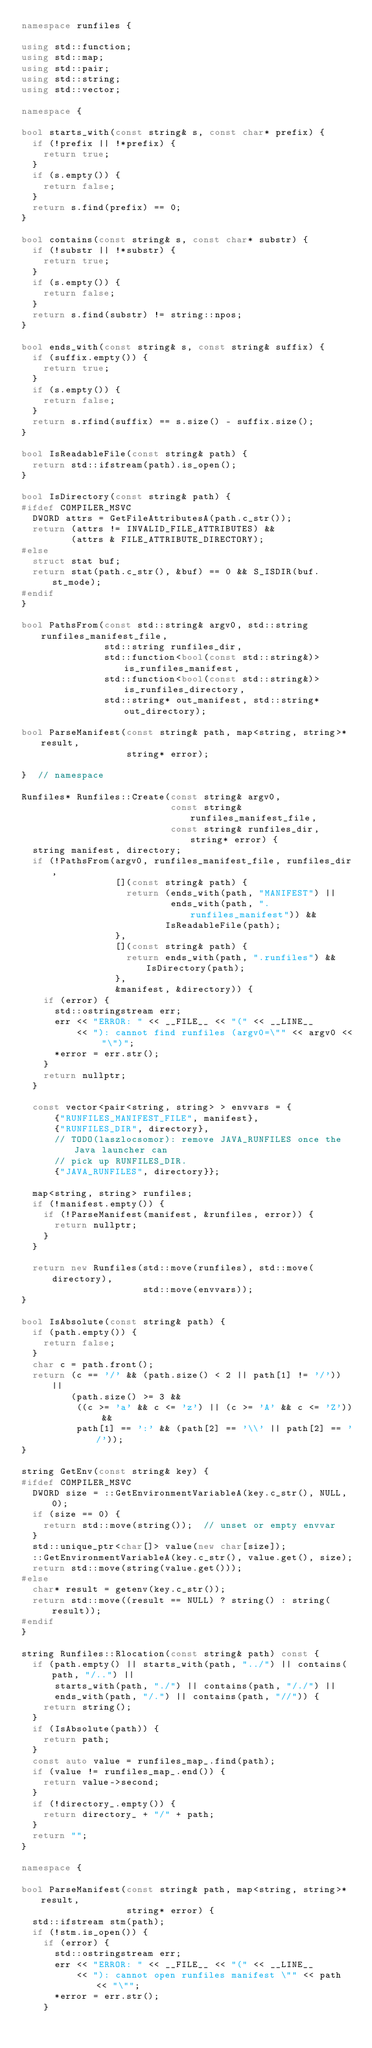Convert code to text. <code><loc_0><loc_0><loc_500><loc_500><_C++_>namespace runfiles {

using std::function;
using std::map;
using std::pair;
using std::string;
using std::vector;

namespace {

bool starts_with(const string& s, const char* prefix) {
  if (!prefix || !*prefix) {
    return true;
  }
  if (s.empty()) {
    return false;
  }
  return s.find(prefix) == 0;
}

bool contains(const string& s, const char* substr) {
  if (!substr || !*substr) {
    return true;
  }
  if (s.empty()) {
    return false;
  }
  return s.find(substr) != string::npos;
}

bool ends_with(const string& s, const string& suffix) {
  if (suffix.empty()) {
    return true;
  }
  if (s.empty()) {
    return false;
  }
  return s.rfind(suffix) == s.size() - suffix.size();
}

bool IsReadableFile(const string& path) {
  return std::ifstream(path).is_open();
}

bool IsDirectory(const string& path) {
#ifdef COMPILER_MSVC
  DWORD attrs = GetFileAttributesA(path.c_str());
  return (attrs != INVALID_FILE_ATTRIBUTES) &&
         (attrs & FILE_ATTRIBUTE_DIRECTORY);
#else
  struct stat buf;
  return stat(path.c_str(), &buf) == 0 && S_ISDIR(buf.st_mode);
#endif
}

bool PathsFrom(const std::string& argv0, std::string runfiles_manifest_file,
               std::string runfiles_dir,
               std::function<bool(const std::string&)> is_runfiles_manifest,
               std::function<bool(const std::string&)> is_runfiles_directory,
               std::string* out_manifest, std::string* out_directory);

bool ParseManifest(const string& path, map<string, string>* result,
                   string* error);

}  // namespace

Runfiles* Runfiles::Create(const string& argv0,
                           const string& runfiles_manifest_file,
                           const string& runfiles_dir, string* error) {
  string manifest, directory;
  if (!PathsFrom(argv0, runfiles_manifest_file, runfiles_dir,
                 [](const string& path) {
                   return (ends_with(path, "MANIFEST") ||
                           ends_with(path, ".runfiles_manifest")) &&
                          IsReadableFile(path);
                 },
                 [](const string& path) {
                   return ends_with(path, ".runfiles") && IsDirectory(path);
                 },
                 &manifest, &directory)) {
    if (error) {
      std::ostringstream err;
      err << "ERROR: " << __FILE__ << "(" << __LINE__
          << "): cannot find runfiles (argv0=\"" << argv0 << "\")";
      *error = err.str();
    }
    return nullptr;
  }

  const vector<pair<string, string> > envvars = {
      {"RUNFILES_MANIFEST_FILE", manifest},
      {"RUNFILES_DIR", directory},
      // TODO(laszlocsomor): remove JAVA_RUNFILES once the Java launcher can
      // pick up RUNFILES_DIR.
      {"JAVA_RUNFILES", directory}};

  map<string, string> runfiles;
  if (!manifest.empty()) {
    if (!ParseManifest(manifest, &runfiles, error)) {
      return nullptr;
    }
  }

  return new Runfiles(std::move(runfiles), std::move(directory),
                      std::move(envvars));
}

bool IsAbsolute(const string& path) {
  if (path.empty()) {
    return false;
  }
  char c = path.front();
  return (c == '/' && (path.size() < 2 || path[1] != '/')) ||
         (path.size() >= 3 &&
          ((c >= 'a' && c <= 'z') || (c >= 'A' && c <= 'Z')) &&
          path[1] == ':' && (path[2] == '\\' || path[2] == '/'));
}

string GetEnv(const string& key) {
#ifdef COMPILER_MSVC
  DWORD size = ::GetEnvironmentVariableA(key.c_str(), NULL, 0);
  if (size == 0) {
    return std::move(string());  // unset or empty envvar
  }
  std::unique_ptr<char[]> value(new char[size]);
  ::GetEnvironmentVariableA(key.c_str(), value.get(), size);
  return std::move(string(value.get()));
#else
  char* result = getenv(key.c_str());
  return std::move((result == NULL) ? string() : string(result));
#endif
}

string Runfiles::Rlocation(const string& path) const {
  if (path.empty() || starts_with(path, "../") || contains(path, "/..") ||
      starts_with(path, "./") || contains(path, "/./") ||
      ends_with(path, "/.") || contains(path, "//")) {
    return string();
  }
  if (IsAbsolute(path)) {
    return path;
  }
  const auto value = runfiles_map_.find(path);
  if (value != runfiles_map_.end()) {
    return value->second;
  }
  if (!directory_.empty()) {
    return directory_ + "/" + path;
  }
  return "";
}

namespace {

bool ParseManifest(const string& path, map<string, string>* result,
                   string* error) {
  std::ifstream stm(path);
  if (!stm.is_open()) {
    if (error) {
      std::ostringstream err;
      err << "ERROR: " << __FILE__ << "(" << __LINE__
          << "): cannot open runfiles manifest \"" << path << "\"";
      *error = err.str();
    }</code> 